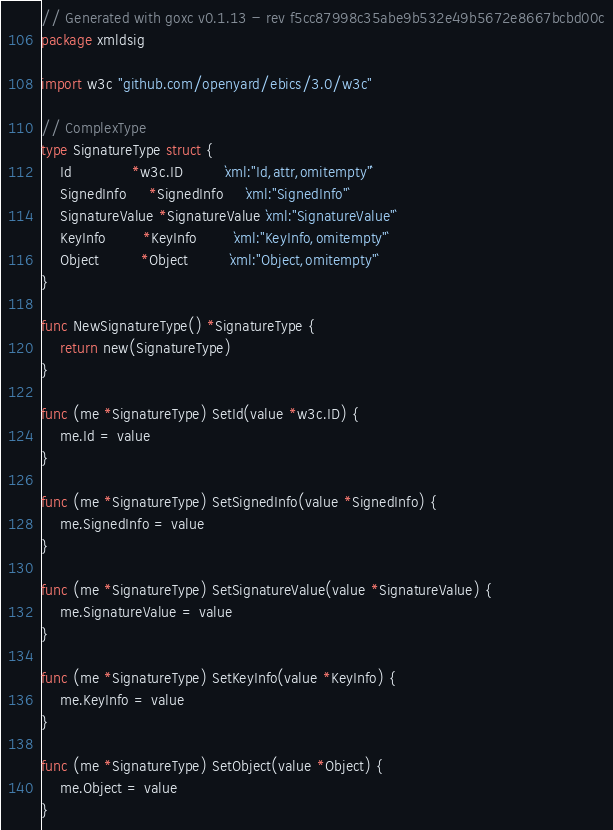Convert code to text. <code><loc_0><loc_0><loc_500><loc_500><_Go_>// Generated with goxc v0.1.13 - rev f5cc87998c35abe9b532e49b5672e8667bcbd00c
package xmldsig

import w3c "github.com/openyard/ebics/3.0/w3c"

// ComplexType
type SignatureType struct {
	Id             *w3c.ID         `xml:"Id,attr,omitempty"`
	SignedInfo     *SignedInfo     `xml:"SignedInfo"`
	SignatureValue *SignatureValue `xml:"SignatureValue"`
	KeyInfo        *KeyInfo        `xml:"KeyInfo,omitempty"`
	Object         *Object         `xml:"Object,omitempty"`
}

func NewSignatureType() *SignatureType {
	return new(SignatureType)
}

func (me *SignatureType) SetId(value *w3c.ID) {
	me.Id = value
}

func (me *SignatureType) SetSignedInfo(value *SignedInfo) {
	me.SignedInfo = value
}

func (me *SignatureType) SetSignatureValue(value *SignatureValue) {
	me.SignatureValue = value
}

func (me *SignatureType) SetKeyInfo(value *KeyInfo) {
	me.KeyInfo = value
}

func (me *SignatureType) SetObject(value *Object) {
	me.Object = value
}
</code> 